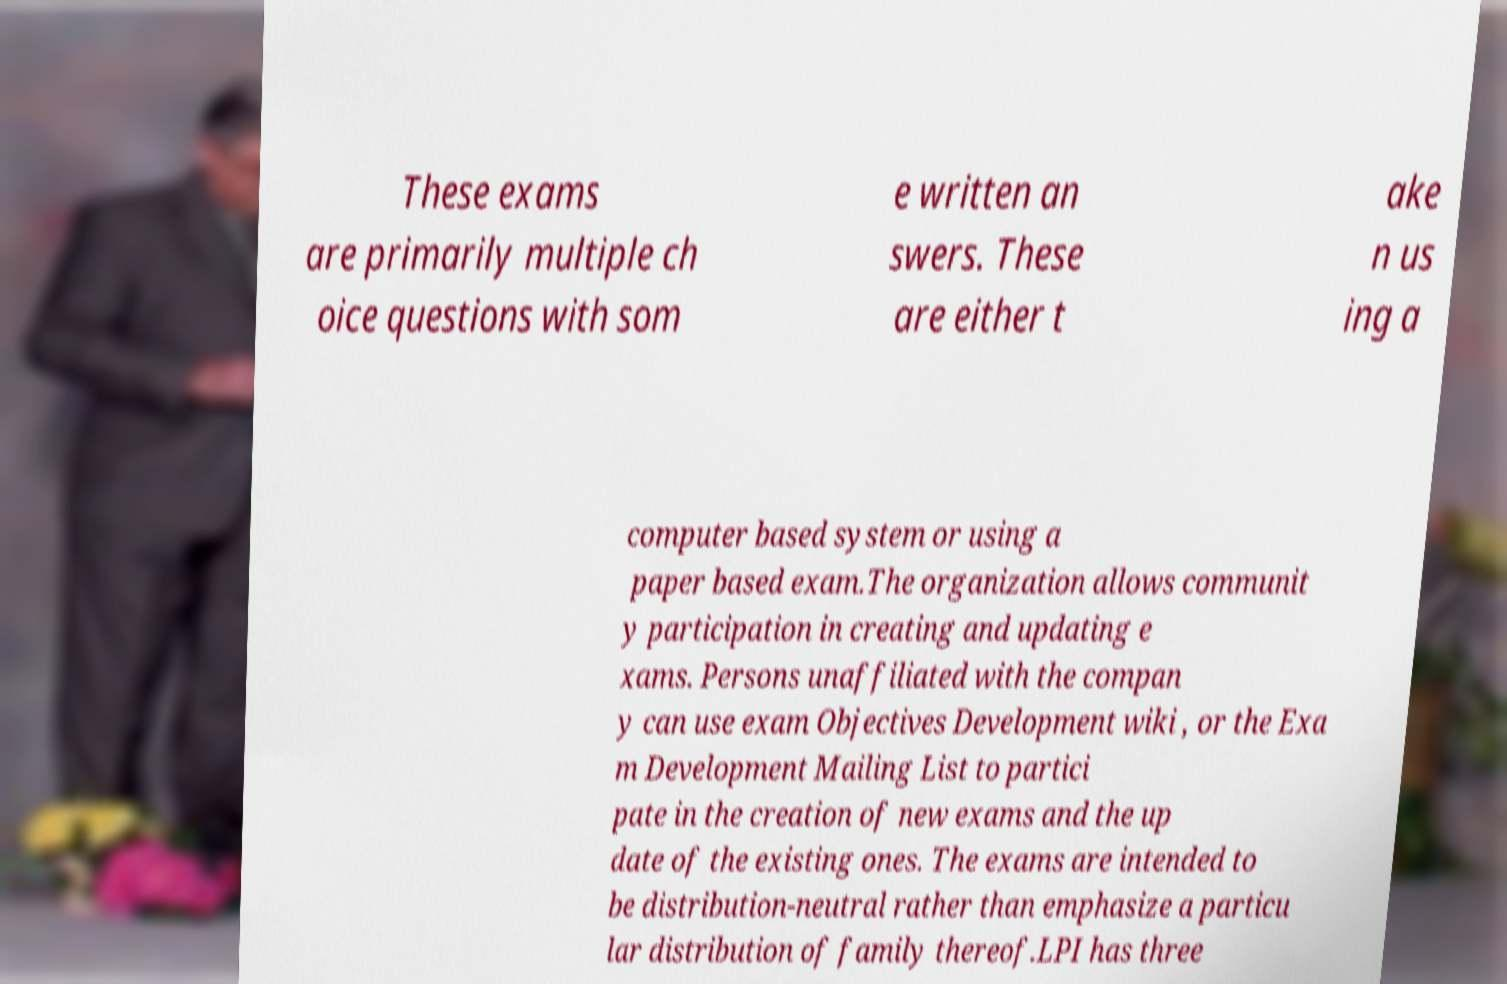Can you read and provide the text displayed in the image?This photo seems to have some interesting text. Can you extract and type it out for me? These exams are primarily multiple ch oice questions with som e written an swers. These are either t ake n us ing a computer based system or using a paper based exam.The organization allows communit y participation in creating and updating e xams. Persons unaffiliated with the compan y can use exam Objectives Development wiki , or the Exa m Development Mailing List to partici pate in the creation of new exams and the up date of the existing ones. The exams are intended to be distribution-neutral rather than emphasize a particu lar distribution of family thereof.LPI has three 